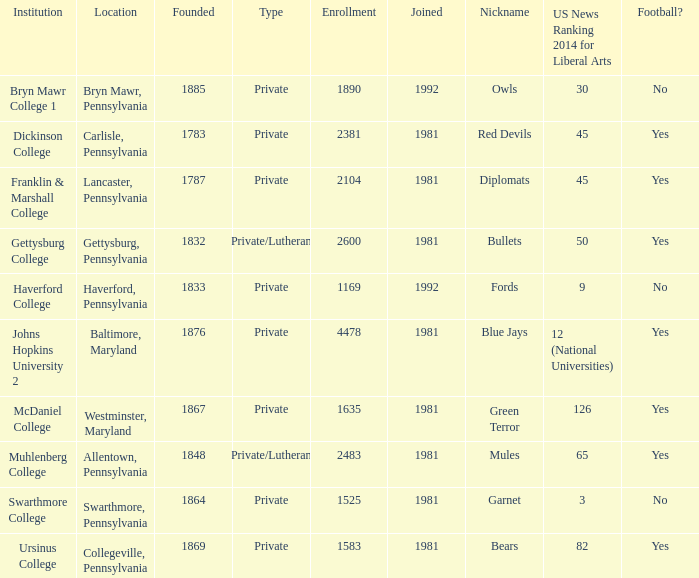What type of school is in swarthmore, pennsylvania? Private. 